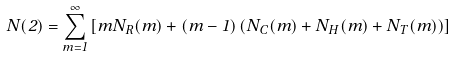<formula> <loc_0><loc_0><loc_500><loc_500>N ( 2 ) = \sum _ { m = 1 } ^ { \infty } \left [ m N _ { R } ( m ) + ( m - 1 ) \left ( N _ { C } ( m ) + N _ { H } ( m ) + N _ { T } ( m ) \right ) \right ]</formula> 